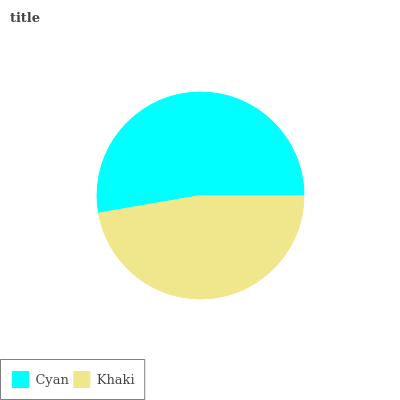Is Khaki the minimum?
Answer yes or no. Yes. Is Cyan the maximum?
Answer yes or no. Yes. Is Khaki the maximum?
Answer yes or no. No. Is Cyan greater than Khaki?
Answer yes or no. Yes. Is Khaki less than Cyan?
Answer yes or no. Yes. Is Khaki greater than Cyan?
Answer yes or no. No. Is Cyan less than Khaki?
Answer yes or no. No. Is Cyan the high median?
Answer yes or no. Yes. Is Khaki the low median?
Answer yes or no. Yes. Is Khaki the high median?
Answer yes or no. No. Is Cyan the low median?
Answer yes or no. No. 